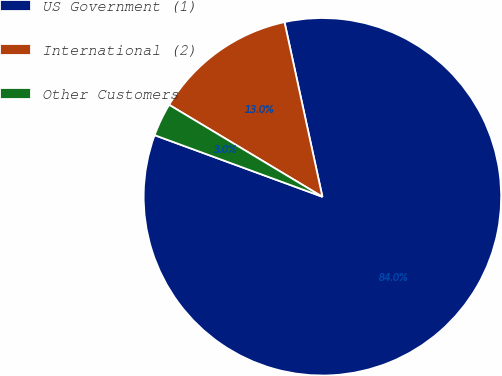Convert chart. <chart><loc_0><loc_0><loc_500><loc_500><pie_chart><fcel>US Government (1)<fcel>International (2)<fcel>Other Customers<nl><fcel>84.0%<fcel>13.0%<fcel>3.0%<nl></chart> 